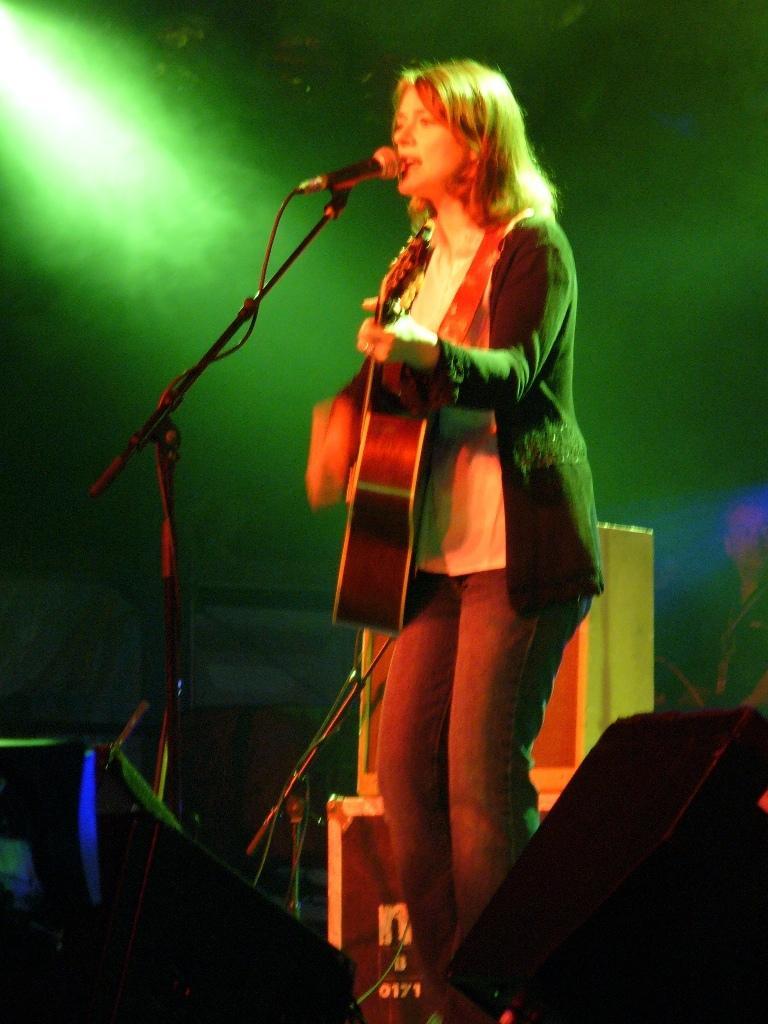Can you describe this image briefly? Middle of the image we can see a woman is playing a guitar and singing in-front of mic. Bottom of the image there are boxes and speakers. Background of the image it is dark and we can see focusing light. 